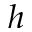Convert formula to latex. <formula><loc_0><loc_0><loc_500><loc_500>h</formula> 